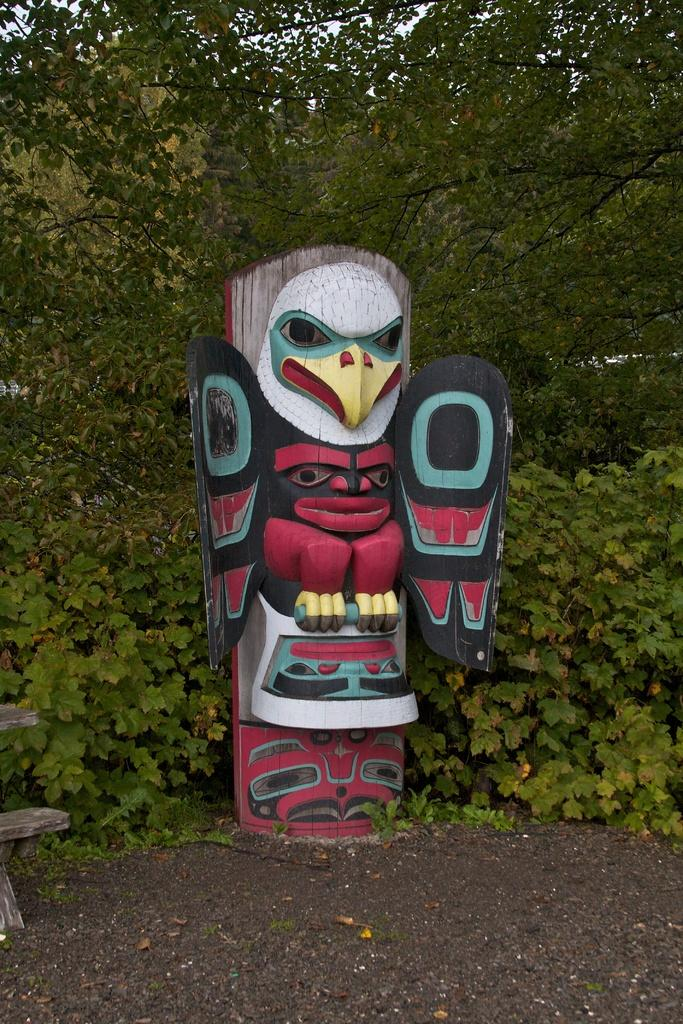What is the main subject in the center of the image? There is a statue in the center of the image. What can be seen in the background of the image? There are trees in the background of the image. What type of oatmeal is being served in the image? There is no oatmeal present in the image; it features a statue and trees in the background. What kind of bubble can be seen floating near the statue? There is no bubble present in the image; it only features a statue and trees in the background. 